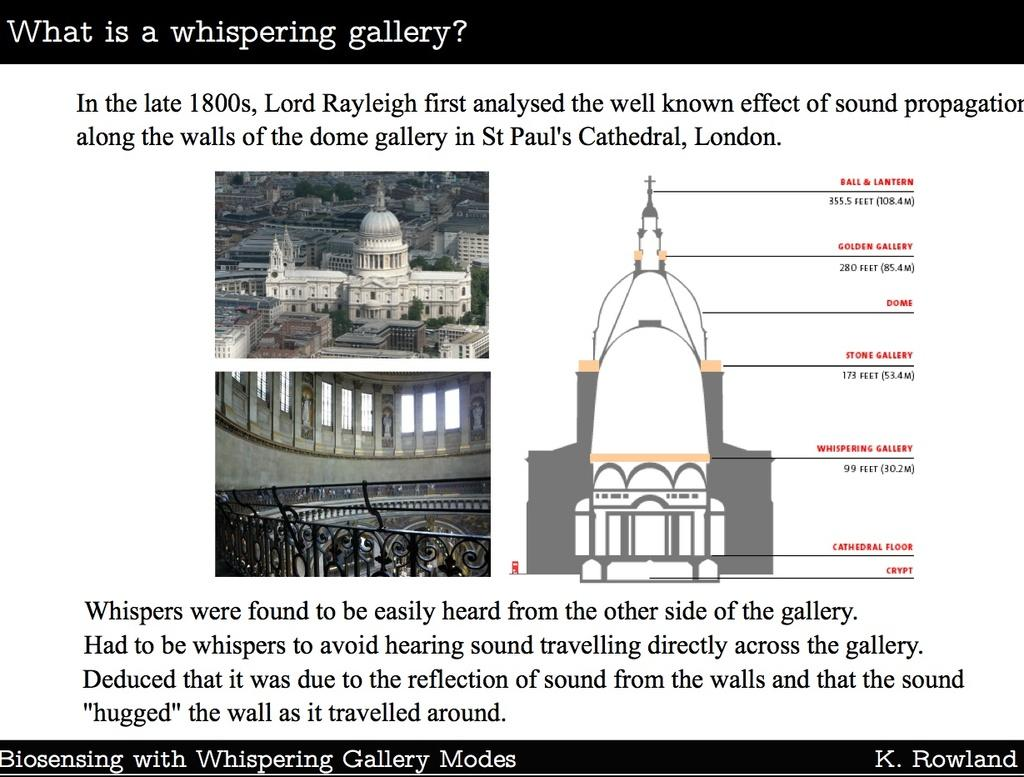Provide a one-sentence caption for the provided image. An overview of what a whispering gallery is by K. Rowland. 